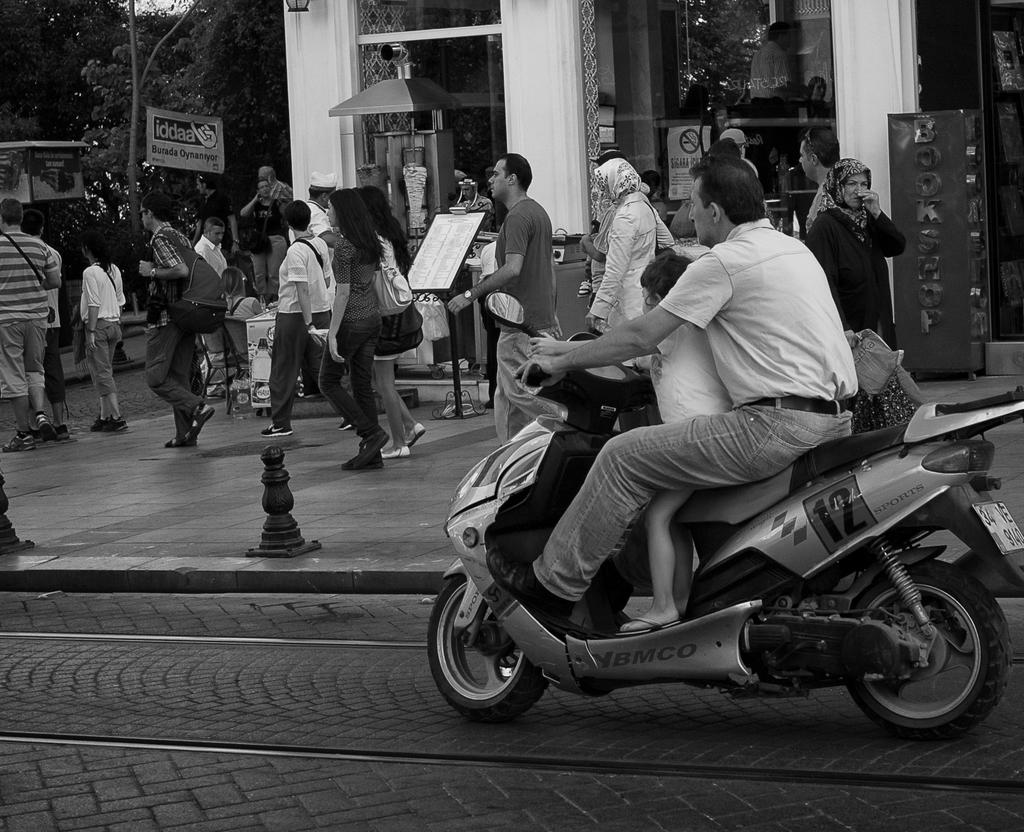What is the man in the image doing? The man is riding a scooter on the road. What are the people in the image doing? The people in the image are walking on the road. What can be seen in the background of the image? There is a building in the background. How many pigs are flying with wings in the image? There are no pigs or wings present in the image. What is the price of the scooter in the image? The image does not provide any information about the price of the scooter. 